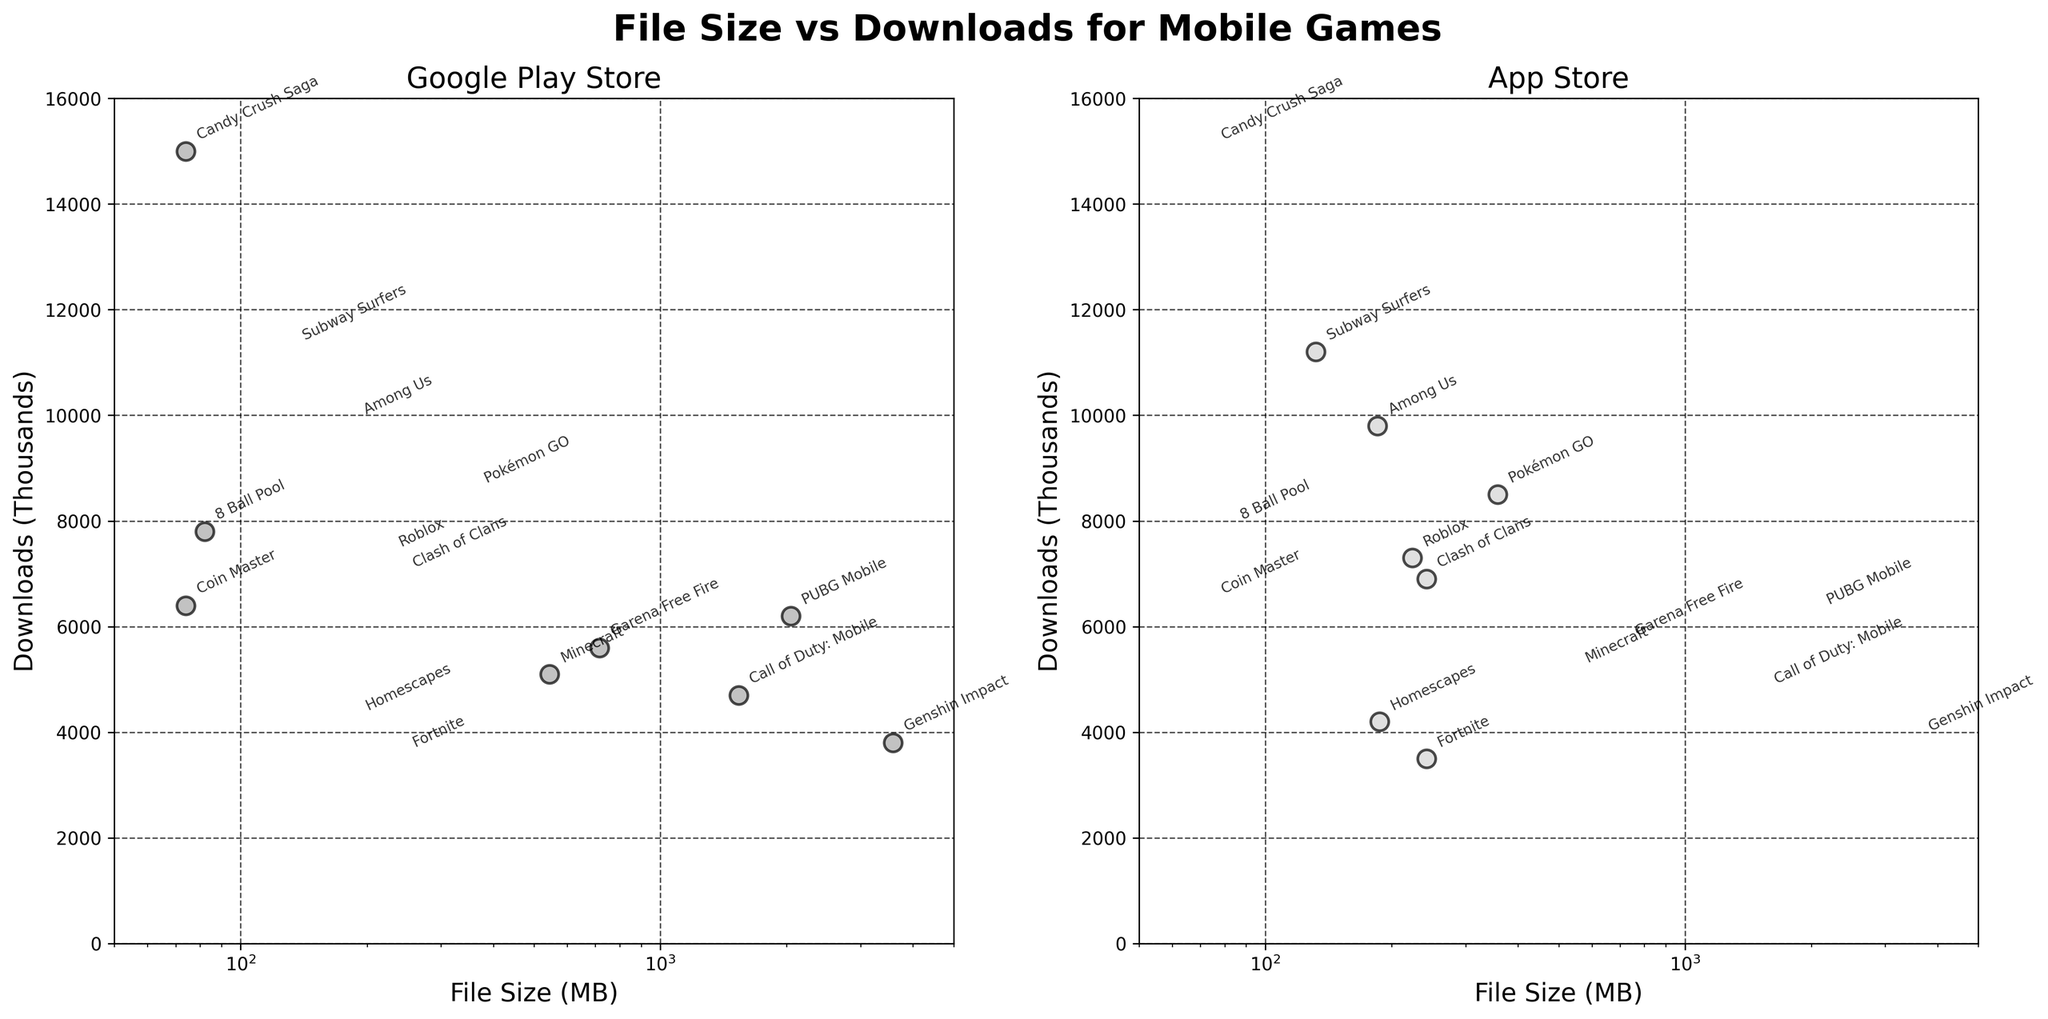What's the title of the figure? The title of a figure is usually written as the largest and most prominent text, typically at the top.
Answer: File Size vs Downloads for Mobile Games What are the axis labels for the Google Play Store plot? The axis labels for the Google Play Store plot are found on the left side (y-axis) and the bottom (x-axis) of the scatter plot. The x-axis label is 'File Size (MB)', and the y-axis label is 'Downloads (Thousands)'.
Answer: File Size (MB), Downloads (Thousands) Which game has the largest file size on the App Store plot? Looking at the x-axis of the App Store plot, find the game with the largest value. Annotated game titles can help identify it.
Answer: Pokémon GO How many games on Google Play have more than 5000 downloads? For each data point in the scatter plot of Google Play, compare the y-axis values to 5000. Count the number of points above this threshold.
Answer: 4 Which game has the highest number of downloads on Google Play and what is its file size? Find the data point with the highest y-axis value on the Google Play plot and refer to the annotated title and the x-axis value for the file size.
Answer: Candy Crush Saga, 74 MB Compare the file sizes of Roblox on the App Store and Minecraft on Google Play. Which one is bigger? Find the points that correspond to Roblox and Minecraft on their respective plots and compare their x-axis values. Roblox has a file size of 224 MB and Minecraft has 545 MB.
Answer: Minecraft Is there a general trend between file size and download numbers for games on Google Play? Look for a pattern or trend in the scatter plot on the Google Play side. Notice whether the downloads tend to increase or decrease with file size.
Answer: No clear trend What is the download difference between the smallest and the largest game file sizes on the App Store plot? Identify the smallest and largest file sizes on the App Store plot, find their corresponding downloads, and compute the difference. Pokémon GO (largest, 8500) and Fortnite (smallest, 3500).
Answer: 5000 Which game has fewer downloads: Genshin Impact on Google Play or Fortnite on the App Store? Compare the y-axis values for Genshin Impact on Google Play and Fortnite on the App Store, find the annotated game titles for confirmation.
Answer: Fortnite What is the color used for points in the Google Play plot? Look at the points on the Google Play plot to identify their color. They are described in the code as having a dark gray color with black edges.
Answer: Dark gray 